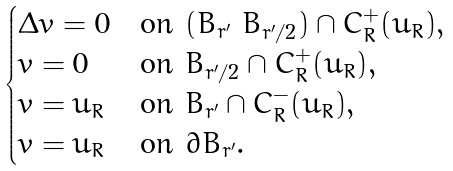<formula> <loc_0><loc_0><loc_500><loc_500>\begin{cases} \Delta v = 0 & \text {on $(B_{r^{\prime}} \ B_{r^{\prime}/2}) \cap C_{R}^{+}(u_{R})$} , \\ v = 0 & \text {on $B_{r^{\prime}/2} \cap C_{R}^{+}(u_{R})$} , \\ v = u _ { R } & \text {on $B_{r^{\prime}} \cap C^{-}_{R}(u_{R})$} , \\ v = u _ { R } & \text {on $\partial B_{r^{\prime}}$} . \end{cases}</formula> 